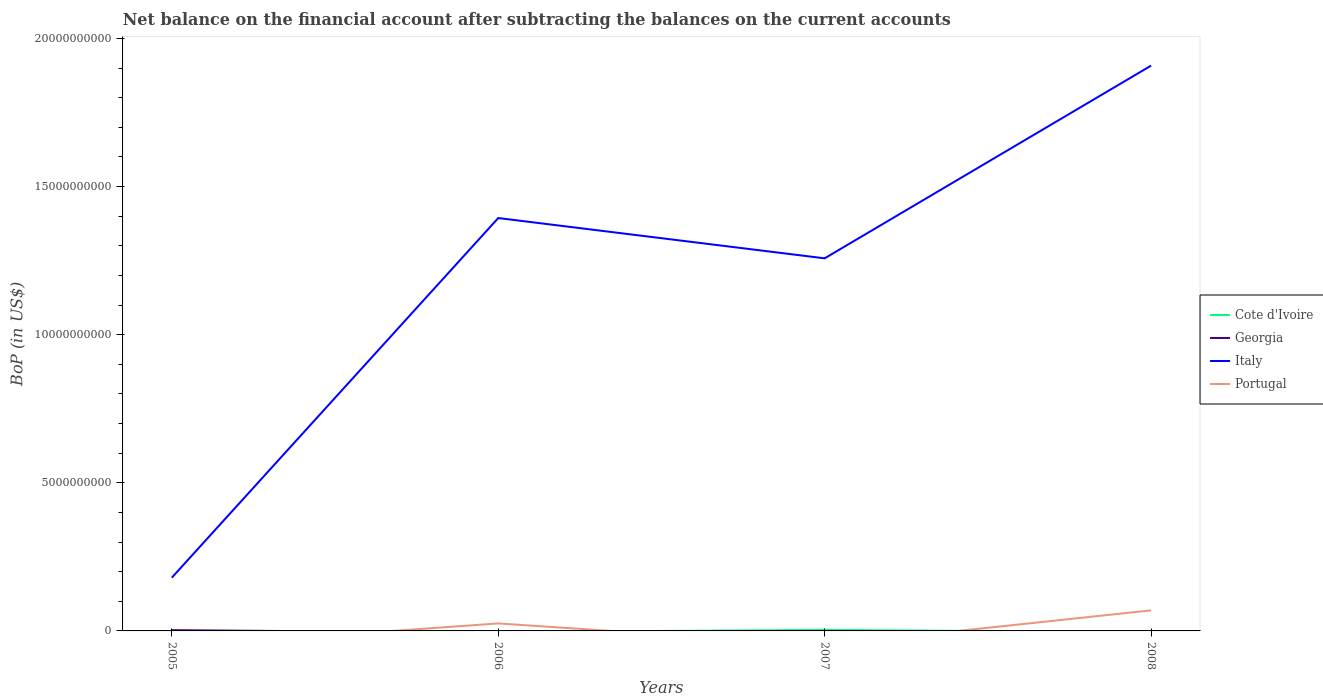How many different coloured lines are there?
Keep it short and to the point. 4. Does the line corresponding to Italy intersect with the line corresponding to Georgia?
Offer a very short reply. No. Is the number of lines equal to the number of legend labels?
Provide a short and direct response. No. What is the difference between the highest and the second highest Balance of Payments in Portugal?
Your answer should be very brief. 6.94e+08. Is the Balance of Payments in Portugal strictly greater than the Balance of Payments in Italy over the years?
Give a very brief answer. Yes. How many lines are there?
Offer a terse response. 4. How many years are there in the graph?
Offer a terse response. 4. Does the graph contain any zero values?
Provide a short and direct response. Yes. Where does the legend appear in the graph?
Provide a short and direct response. Center right. How are the legend labels stacked?
Your answer should be very brief. Vertical. What is the title of the graph?
Offer a very short reply. Net balance on the financial account after subtracting the balances on the current accounts. Does "Lithuania" appear as one of the legend labels in the graph?
Ensure brevity in your answer.  No. What is the label or title of the X-axis?
Ensure brevity in your answer.  Years. What is the label or title of the Y-axis?
Your response must be concise. BoP (in US$). What is the BoP (in US$) in Cote d'Ivoire in 2005?
Offer a very short reply. 0. What is the BoP (in US$) in Georgia in 2005?
Give a very brief answer. 2.65e+07. What is the BoP (in US$) in Italy in 2005?
Your answer should be very brief. 1.80e+09. What is the BoP (in US$) of Portugal in 2005?
Your answer should be compact. 0. What is the BoP (in US$) in Cote d'Ivoire in 2006?
Give a very brief answer. 0. What is the BoP (in US$) of Italy in 2006?
Your answer should be compact. 1.39e+1. What is the BoP (in US$) in Portugal in 2006?
Ensure brevity in your answer.  2.53e+08. What is the BoP (in US$) in Cote d'Ivoire in 2007?
Provide a short and direct response. 3.52e+07. What is the BoP (in US$) in Italy in 2007?
Make the answer very short. 1.26e+1. What is the BoP (in US$) in Georgia in 2008?
Keep it short and to the point. 0. What is the BoP (in US$) of Italy in 2008?
Keep it short and to the point. 1.91e+1. What is the BoP (in US$) in Portugal in 2008?
Your answer should be compact. 6.94e+08. Across all years, what is the maximum BoP (in US$) of Cote d'Ivoire?
Give a very brief answer. 3.52e+07. Across all years, what is the maximum BoP (in US$) in Georgia?
Offer a terse response. 2.65e+07. Across all years, what is the maximum BoP (in US$) in Italy?
Make the answer very short. 1.91e+1. Across all years, what is the maximum BoP (in US$) in Portugal?
Offer a terse response. 6.94e+08. Across all years, what is the minimum BoP (in US$) of Italy?
Your response must be concise. 1.80e+09. What is the total BoP (in US$) of Cote d'Ivoire in the graph?
Offer a very short reply. 3.52e+07. What is the total BoP (in US$) of Georgia in the graph?
Keep it short and to the point. 2.65e+07. What is the total BoP (in US$) in Italy in the graph?
Your response must be concise. 4.74e+1. What is the total BoP (in US$) of Portugal in the graph?
Provide a succinct answer. 9.48e+08. What is the difference between the BoP (in US$) in Italy in 2005 and that in 2006?
Ensure brevity in your answer.  -1.21e+1. What is the difference between the BoP (in US$) of Italy in 2005 and that in 2007?
Make the answer very short. -1.08e+1. What is the difference between the BoP (in US$) of Italy in 2005 and that in 2008?
Ensure brevity in your answer.  -1.73e+1. What is the difference between the BoP (in US$) in Italy in 2006 and that in 2007?
Offer a very short reply. 1.36e+09. What is the difference between the BoP (in US$) in Italy in 2006 and that in 2008?
Offer a terse response. -5.15e+09. What is the difference between the BoP (in US$) in Portugal in 2006 and that in 2008?
Offer a terse response. -4.41e+08. What is the difference between the BoP (in US$) in Italy in 2007 and that in 2008?
Keep it short and to the point. -6.51e+09. What is the difference between the BoP (in US$) in Georgia in 2005 and the BoP (in US$) in Italy in 2006?
Your answer should be very brief. -1.39e+1. What is the difference between the BoP (in US$) of Georgia in 2005 and the BoP (in US$) of Portugal in 2006?
Ensure brevity in your answer.  -2.27e+08. What is the difference between the BoP (in US$) of Italy in 2005 and the BoP (in US$) of Portugal in 2006?
Keep it short and to the point. 1.55e+09. What is the difference between the BoP (in US$) in Georgia in 2005 and the BoP (in US$) in Italy in 2007?
Ensure brevity in your answer.  -1.26e+1. What is the difference between the BoP (in US$) of Georgia in 2005 and the BoP (in US$) of Italy in 2008?
Provide a short and direct response. -1.91e+1. What is the difference between the BoP (in US$) of Georgia in 2005 and the BoP (in US$) of Portugal in 2008?
Keep it short and to the point. -6.68e+08. What is the difference between the BoP (in US$) of Italy in 2005 and the BoP (in US$) of Portugal in 2008?
Ensure brevity in your answer.  1.10e+09. What is the difference between the BoP (in US$) in Italy in 2006 and the BoP (in US$) in Portugal in 2008?
Provide a succinct answer. 1.32e+1. What is the difference between the BoP (in US$) in Cote d'Ivoire in 2007 and the BoP (in US$) in Italy in 2008?
Keep it short and to the point. -1.90e+1. What is the difference between the BoP (in US$) in Cote d'Ivoire in 2007 and the BoP (in US$) in Portugal in 2008?
Give a very brief answer. -6.59e+08. What is the difference between the BoP (in US$) of Italy in 2007 and the BoP (in US$) of Portugal in 2008?
Ensure brevity in your answer.  1.19e+1. What is the average BoP (in US$) in Cote d'Ivoire per year?
Provide a short and direct response. 8.80e+06. What is the average BoP (in US$) of Georgia per year?
Offer a very short reply. 6.63e+06. What is the average BoP (in US$) in Italy per year?
Ensure brevity in your answer.  1.19e+1. What is the average BoP (in US$) in Portugal per year?
Your answer should be compact. 2.37e+08. In the year 2005, what is the difference between the BoP (in US$) of Georgia and BoP (in US$) of Italy?
Offer a terse response. -1.77e+09. In the year 2006, what is the difference between the BoP (in US$) in Italy and BoP (in US$) in Portugal?
Offer a very short reply. 1.37e+1. In the year 2007, what is the difference between the BoP (in US$) of Cote d'Ivoire and BoP (in US$) of Italy?
Offer a very short reply. -1.25e+1. In the year 2008, what is the difference between the BoP (in US$) in Italy and BoP (in US$) in Portugal?
Your answer should be very brief. 1.84e+1. What is the ratio of the BoP (in US$) in Italy in 2005 to that in 2006?
Give a very brief answer. 0.13. What is the ratio of the BoP (in US$) of Italy in 2005 to that in 2007?
Provide a succinct answer. 0.14. What is the ratio of the BoP (in US$) of Italy in 2005 to that in 2008?
Provide a short and direct response. 0.09. What is the ratio of the BoP (in US$) in Italy in 2006 to that in 2007?
Keep it short and to the point. 1.11. What is the ratio of the BoP (in US$) of Italy in 2006 to that in 2008?
Offer a terse response. 0.73. What is the ratio of the BoP (in US$) in Portugal in 2006 to that in 2008?
Ensure brevity in your answer.  0.36. What is the ratio of the BoP (in US$) in Italy in 2007 to that in 2008?
Your answer should be compact. 0.66. What is the difference between the highest and the second highest BoP (in US$) of Italy?
Provide a short and direct response. 5.15e+09. What is the difference between the highest and the lowest BoP (in US$) of Cote d'Ivoire?
Your response must be concise. 3.52e+07. What is the difference between the highest and the lowest BoP (in US$) of Georgia?
Provide a short and direct response. 2.65e+07. What is the difference between the highest and the lowest BoP (in US$) of Italy?
Your response must be concise. 1.73e+1. What is the difference between the highest and the lowest BoP (in US$) in Portugal?
Offer a terse response. 6.94e+08. 